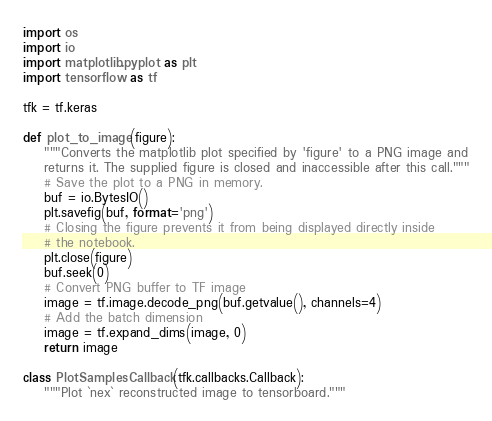Convert code to text. <code><loc_0><loc_0><loc_500><loc_500><_Python_>import os
import io
import matplotlib.pyplot as plt
import tensorflow as tf

tfk = tf.keras

def plot_to_image(figure):
    """Converts the matplotlib plot specified by 'figure' to a PNG image and
    returns it. The supplied figure is closed and inaccessible after this call."""
    # Save the plot to a PNG in memory.
    buf = io.BytesIO()
    plt.savefig(buf, format='png')
    # Closing the figure prevents it from being displayed directly inside
    # the notebook.
    plt.close(figure)
    buf.seek(0)
    # Convert PNG buffer to TF image
    image = tf.image.decode_png(buf.getvalue(), channels=4)
    # Add the batch dimension
    image = tf.expand_dims(image, 0)
    return image

class PlotSamplesCallback(tfk.callbacks.Callback):
    """Plot `nex` reconstructed image to tensorboard."""</code> 